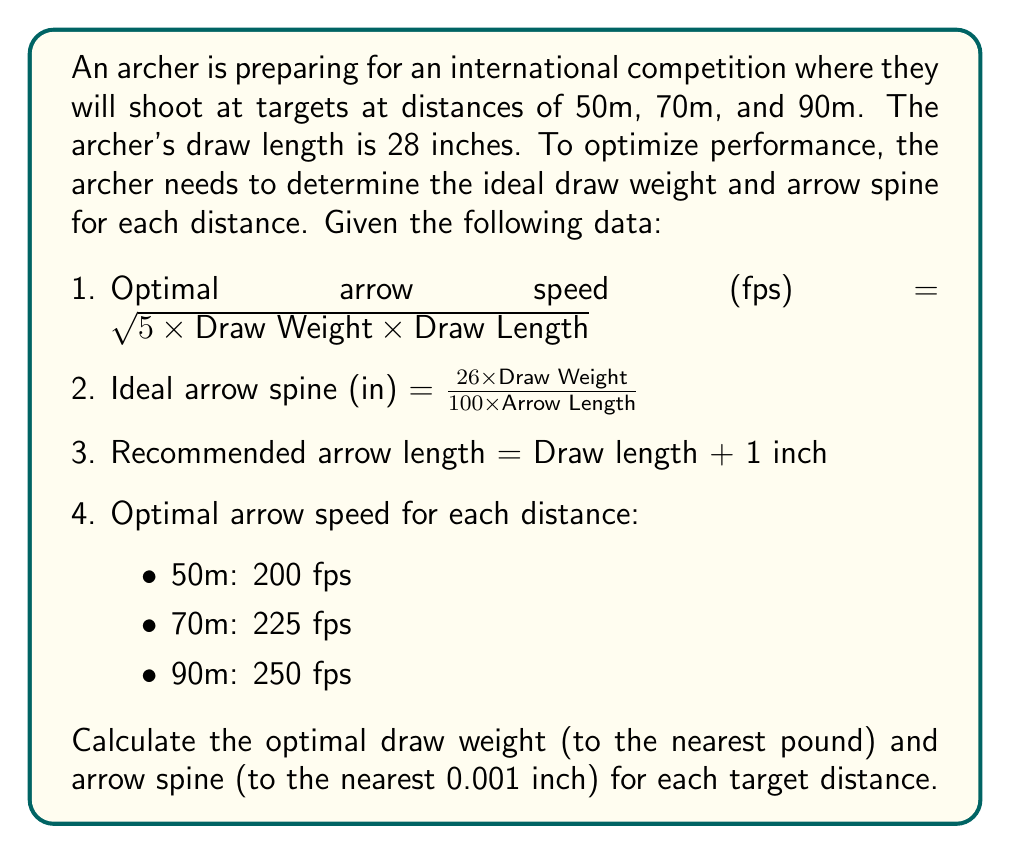Teach me how to tackle this problem. Let's approach this problem step by step for each target distance:

1. First, we need to calculate the arrow length:
   Arrow length = Draw length + 1 inch = 28 + 1 = 29 inches

2. Now, let's solve for each distance:

For 50m (200 fps):
a) Using the optimal arrow speed formula:
   $$200 = \sqrt{5 \times \text{Draw Weight} \times 28}$$
b) Solving for Draw Weight:
   $$40000 = 140 \times \text{Draw Weight}$$
   $$\text{Draw Weight} = \frac{40000}{140} \approx 285.71 \text{ lbs}$$
   Rounding to the nearest pound: 286 lbs

c) Calculate arrow spine:
   $$\text{Arrow Spine} = \frac{26 \times 286}{100 \times 29} \approx 0.256 \text{ inches}$$

For 70m (225 fps):
a) $$225 = \sqrt{5 \times \text{Draw Weight} \times 28}$$
b) $$50625 = 140 \times \text{Draw Weight}$$
   $$\text{Draw Weight} = \frac{50625}{140} \approx 361.61 \text{ lbs}$$
   Rounding to the nearest pound: 362 lbs

c) $$\text{Arrow Spine} = \frac{26 \times 362}{100 \times 29} \approx 0.324 \text{ inches}$$

For 90m (250 fps):
a) $$250 = \sqrt{5 \times \text{Draw Weight} \times 28}$$
b) $$62500 = 140 \times \text{Draw Weight}$$
   $$\text{Draw Weight} = \frac{62500}{140} \approx 446.43 \text{ lbs}$$
   Rounding to the nearest pound: 446 lbs

c) $$\text{Arrow Spine} = \frac{26 \times 446}{100 \times 29} \approx 0.400 \text{ inches}$$
Answer: 50m: Draw Weight = 286 lbs, Arrow Spine = 0.256 inches
70m: Draw Weight = 362 lbs, Arrow Spine = 0.324 inches
90m: Draw Weight = 446 lbs, Arrow Spine = 0.400 inches 